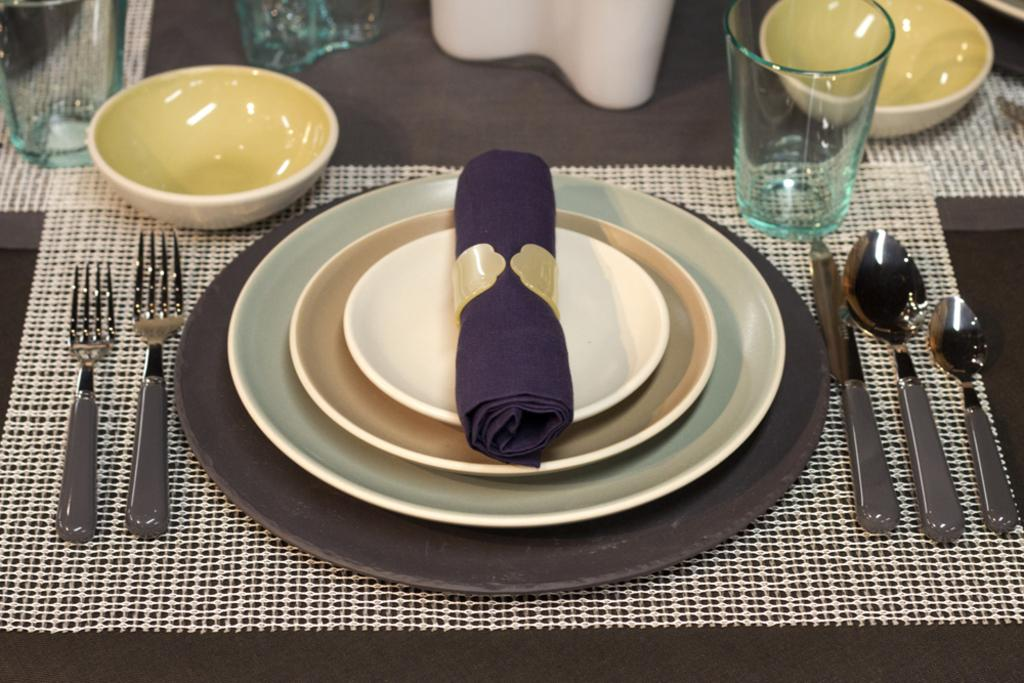What type of furniture is present in the image? There is a table in the image. What utensils can be seen on the table? There are forks, knives, and spoons on the table. What type of dishware is present on the table? There are plates and bowls on the table. What type of beverage container is present on the table? There are glasses on the table. What type of covering is on the table? There is a cloth on the table. What type of meal is being prepared for the deer in the image? There is no deer present in the image, and no meal is being prepared. Can you describe the haircut of the person in the image? There is no person present in the image, and therefore no haircut to describe. 